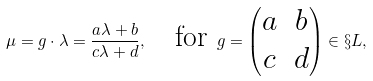Convert formula to latex. <formula><loc_0><loc_0><loc_500><loc_500>\mu = g \cdot \lambda = \frac { a \lambda + b } { c \lambda + d } , \quad \text {for   } g = \begin{pmatrix} a & b \\ c & d \end{pmatrix} \in \S L ,</formula> 